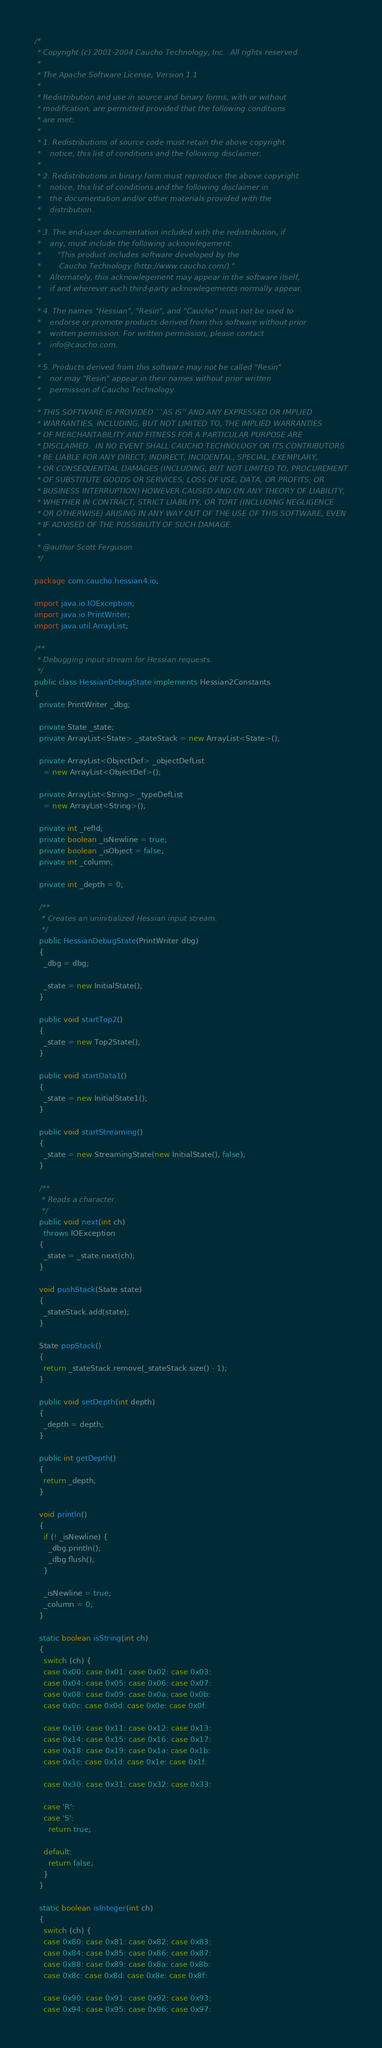Convert code to text. <code><loc_0><loc_0><loc_500><loc_500><_Java_>/*
 * Copyright (c) 2001-2004 Caucho Technology, Inc.  All rights reserved.
 *
 * The Apache Software License, Version 1.1
 *
 * Redistribution and use in source and binary forms, with or without
 * modification, are permitted provided that the following conditions
 * are met:
 *
 * 1. Redistributions of source code must retain the above copyright
 *    notice, this list of conditions and the following disclaimer.
 *
 * 2. Redistributions in binary form must reproduce the above copyright
 *    notice, this list of conditions and the following disclaimer in
 *    the documentation and/or other materials provided with the
 *    distribution.
 *
 * 3. The end-user documentation included with the redistribution, if
 *    any, must include the following acknowlegement:
 *       "This product includes software developed by the
 *        Caucho Technology (http://www.caucho.com/)."
 *    Alternately, this acknowlegement may appear in the software itself,
 *    if and wherever such third-party acknowlegements normally appear.
 *
 * 4. The names "Hessian", "Resin", and "Caucho" must not be used to
 *    endorse or promote products derived from this software without prior
 *    written permission. For written permission, please contact
 *    info@caucho.com.
 *
 * 5. Products derived from this software may not be called "Resin"
 *    nor may "Resin" appear in their names without prior written
 *    permission of Caucho Technology.
 *
 * THIS SOFTWARE IS PROVIDED ``AS IS'' AND ANY EXPRESSED OR IMPLIED
 * WARRANTIES, INCLUDING, BUT NOT LIMITED TO, THE IMPLIED WARRANTIES
 * OF MERCHANTABILITY AND FITNESS FOR A PARTICULAR PURPOSE ARE
 * DISCLAIMED.  IN NO EVENT SHALL CAUCHO TECHNOLOGY OR ITS CONTRIBUTORS
 * BE LIABLE FOR ANY DIRECT, INDIRECT, INCIDENTAL, SPECIAL, EXEMPLARY,
 * OR CONSEQUENTIAL DAMAGES (INCLUDING, BUT NOT LIMITED TO, PROCUREMENT
 * OF SUBSTITUTE GOODS OR SERVICES; LOSS OF USE, DATA, OR PROFITS; OR
 * BUSINESS INTERRUPTION) HOWEVER CAUSED AND ON ANY THEORY OF LIABILITY,
 * WHETHER IN CONTRACT, STRICT LIABILITY, OR TORT (INCLUDING NEGLIGENCE
 * OR OTHERWISE) ARISING IN ANY WAY OUT OF THE USE OF THIS SOFTWARE, EVEN
 * IF ADVISED OF THE POSSIBILITY OF SUCH DAMAGE.
 *
 * @author Scott Ferguson
 */

package com.caucho.hessian4.io;

import java.io.IOException;
import java.io.PrintWriter;
import java.util.ArrayList;

/**
 * Debugging input stream for Hessian requests.
 */
public class HessianDebugState implements Hessian2Constants
{
  private PrintWriter _dbg;

  private State _state;
  private ArrayList<State> _stateStack = new ArrayList<State>();

  private ArrayList<ObjectDef> _objectDefList
    = new ArrayList<ObjectDef>();

  private ArrayList<String> _typeDefList
    = new ArrayList<String>();

  private int _refId;
  private boolean _isNewline = true;
  private boolean _isObject = false;
  private int _column;

  private int _depth = 0;
  
  /**
   * Creates an uninitialized Hessian input stream.
   */
  public HessianDebugState(PrintWriter dbg)
  {
    _dbg = dbg;

    _state = new InitialState();
  }

  public void startTop2()
  {
    _state = new Top2State();
  }

  public void startData1()
  {
    _state = new InitialState1();
  }

  public void startStreaming()
  {
    _state = new StreamingState(new InitialState(), false);
  }

  /**
   * Reads a character.
   */
  public void next(int ch)
    throws IOException
  {
    _state = _state.next(ch);
  }

  void pushStack(State state)
  {
    _stateStack.add(state);
  }

  State popStack()
  {
    return _stateStack.remove(_stateStack.size() - 1);
  }

  public void setDepth(int depth)
  {
    _depth = depth;
  }

  public int getDepth()
  {
    return _depth;
  }

  void println()
  {
    if (! _isNewline) {
      _dbg.println();
      _dbg.flush();
    }

    _isNewline = true;
    _column = 0;
  }

  static boolean isString(int ch)
  {
    switch (ch) {
    case 0x00: case 0x01: case 0x02: case 0x03:
    case 0x04: case 0x05: case 0x06: case 0x07:
    case 0x08: case 0x09: case 0x0a: case 0x0b:
    case 0x0c: case 0x0d: case 0x0e: case 0x0f:
	
    case 0x10: case 0x11: case 0x12: case 0x13:
    case 0x14: case 0x15: case 0x16: case 0x17:
    case 0x18: case 0x19: case 0x1a: case 0x1b:
    case 0x1c: case 0x1d: case 0x1e: case 0x1f:

    case 0x30: case 0x31: case 0x32: case 0x33:
	
    case 'R':
    case 'S':
      return true;
	
    default:
      return false;
    }
  }

  static boolean isInteger(int ch)
  {
    switch (ch) {
    case 0x80: case 0x81: case 0x82: case 0x83: 
    case 0x84: case 0x85: case 0x86: case 0x87: 
    case 0x88: case 0x89: case 0x8a: case 0x8b: 
    case 0x8c: case 0x8d: case 0x8e: case 0x8f: 

    case 0x90: case 0x91: case 0x92: case 0x93: 
    case 0x94: case 0x95: case 0x96: case 0x97: </code> 